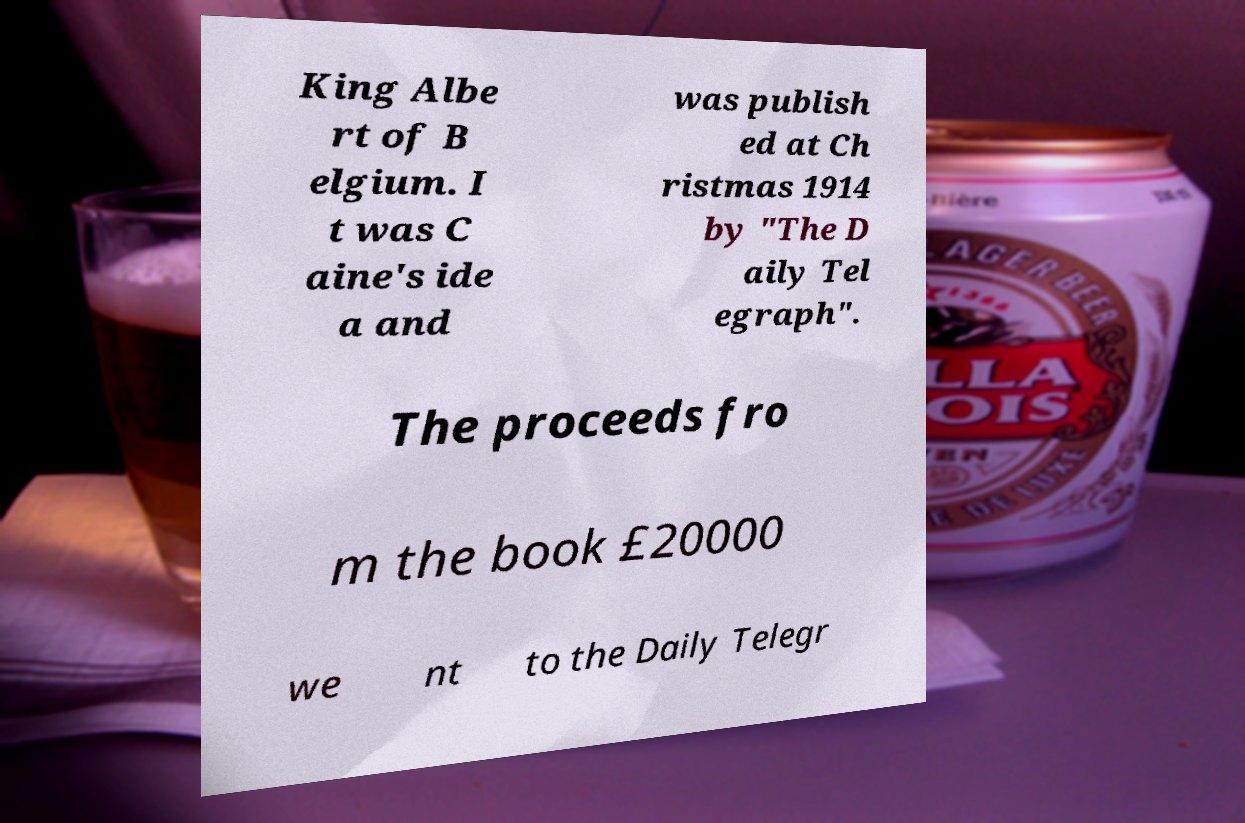Could you extract and type out the text from this image? King Albe rt of B elgium. I t was C aine's ide a and was publish ed at Ch ristmas 1914 by "The D aily Tel egraph". The proceeds fro m the book £20000 we nt to the Daily Telegr 